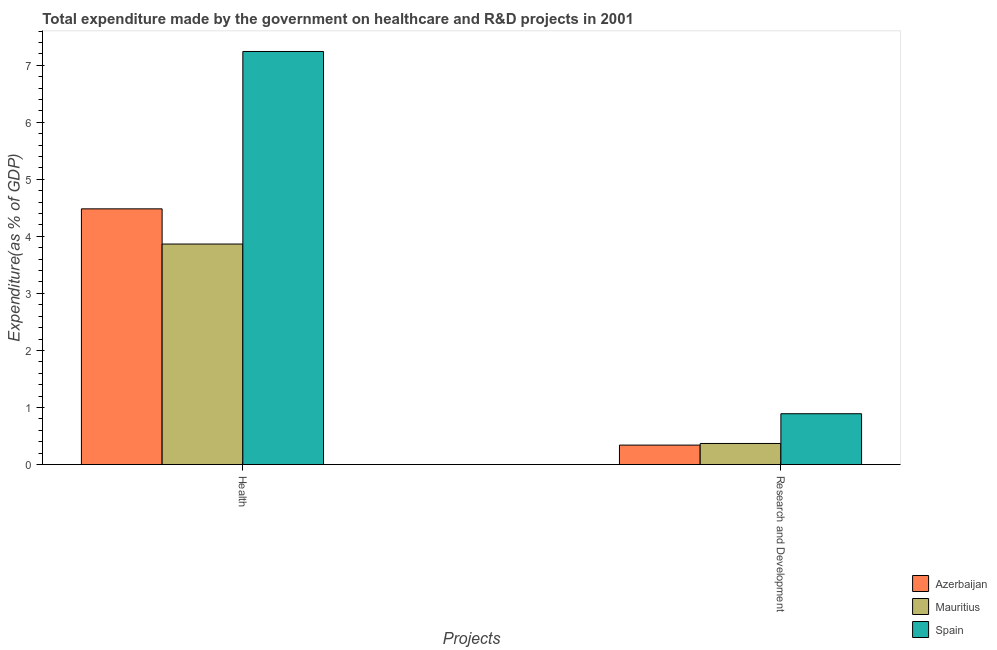Are the number of bars per tick equal to the number of legend labels?
Make the answer very short. Yes. What is the label of the 1st group of bars from the left?
Give a very brief answer. Health. What is the expenditure in r&d in Mauritius?
Your answer should be very brief. 0.37. Across all countries, what is the maximum expenditure in r&d?
Keep it short and to the point. 0.89. Across all countries, what is the minimum expenditure in healthcare?
Make the answer very short. 3.87. In which country was the expenditure in r&d maximum?
Make the answer very short. Spain. In which country was the expenditure in healthcare minimum?
Your answer should be compact. Mauritius. What is the total expenditure in r&d in the graph?
Keep it short and to the point. 1.6. What is the difference between the expenditure in healthcare in Spain and that in Mauritius?
Your answer should be compact. 3.38. What is the difference between the expenditure in r&d in Mauritius and the expenditure in healthcare in Spain?
Give a very brief answer. -6.87. What is the average expenditure in healthcare per country?
Make the answer very short. 5.2. What is the difference between the expenditure in healthcare and expenditure in r&d in Azerbaijan?
Ensure brevity in your answer.  4.14. In how many countries, is the expenditure in healthcare greater than 2.4 %?
Offer a terse response. 3. What is the ratio of the expenditure in healthcare in Spain to that in Azerbaijan?
Your response must be concise. 1.62. In how many countries, is the expenditure in r&d greater than the average expenditure in r&d taken over all countries?
Your response must be concise. 1. What does the 2nd bar from the right in Health represents?
Your answer should be compact. Mauritius. How many bars are there?
Make the answer very short. 6. How are the legend labels stacked?
Give a very brief answer. Vertical. What is the title of the graph?
Your answer should be very brief. Total expenditure made by the government on healthcare and R&D projects in 2001. Does "New Caledonia" appear as one of the legend labels in the graph?
Your response must be concise. No. What is the label or title of the X-axis?
Offer a terse response. Projects. What is the label or title of the Y-axis?
Your answer should be very brief. Expenditure(as % of GDP). What is the Expenditure(as % of GDP) of Azerbaijan in Health?
Provide a succinct answer. 4.48. What is the Expenditure(as % of GDP) in Mauritius in Health?
Your response must be concise. 3.87. What is the Expenditure(as % of GDP) in Spain in Health?
Provide a succinct answer. 7.24. What is the Expenditure(as % of GDP) in Azerbaijan in Research and Development?
Your answer should be very brief. 0.34. What is the Expenditure(as % of GDP) in Mauritius in Research and Development?
Give a very brief answer. 0.37. What is the Expenditure(as % of GDP) of Spain in Research and Development?
Ensure brevity in your answer.  0.89. Across all Projects, what is the maximum Expenditure(as % of GDP) of Azerbaijan?
Offer a terse response. 4.48. Across all Projects, what is the maximum Expenditure(as % of GDP) in Mauritius?
Give a very brief answer. 3.87. Across all Projects, what is the maximum Expenditure(as % of GDP) of Spain?
Offer a terse response. 7.24. Across all Projects, what is the minimum Expenditure(as % of GDP) in Azerbaijan?
Offer a very short reply. 0.34. Across all Projects, what is the minimum Expenditure(as % of GDP) in Mauritius?
Offer a very short reply. 0.37. Across all Projects, what is the minimum Expenditure(as % of GDP) in Spain?
Make the answer very short. 0.89. What is the total Expenditure(as % of GDP) of Azerbaijan in the graph?
Ensure brevity in your answer.  4.82. What is the total Expenditure(as % of GDP) in Mauritius in the graph?
Offer a terse response. 4.23. What is the total Expenditure(as % of GDP) of Spain in the graph?
Make the answer very short. 8.13. What is the difference between the Expenditure(as % of GDP) of Azerbaijan in Health and that in Research and Development?
Keep it short and to the point. 4.14. What is the difference between the Expenditure(as % of GDP) in Mauritius in Health and that in Research and Development?
Provide a short and direct response. 3.5. What is the difference between the Expenditure(as % of GDP) of Spain in Health and that in Research and Development?
Offer a very short reply. 6.35. What is the difference between the Expenditure(as % of GDP) in Azerbaijan in Health and the Expenditure(as % of GDP) in Mauritius in Research and Development?
Your response must be concise. 4.11. What is the difference between the Expenditure(as % of GDP) in Azerbaijan in Health and the Expenditure(as % of GDP) in Spain in Research and Development?
Ensure brevity in your answer.  3.59. What is the difference between the Expenditure(as % of GDP) of Mauritius in Health and the Expenditure(as % of GDP) of Spain in Research and Development?
Your answer should be compact. 2.98. What is the average Expenditure(as % of GDP) in Azerbaijan per Projects?
Your answer should be very brief. 2.41. What is the average Expenditure(as % of GDP) in Mauritius per Projects?
Your response must be concise. 2.12. What is the average Expenditure(as % of GDP) of Spain per Projects?
Offer a terse response. 4.07. What is the difference between the Expenditure(as % of GDP) in Azerbaijan and Expenditure(as % of GDP) in Mauritius in Health?
Offer a terse response. 0.62. What is the difference between the Expenditure(as % of GDP) of Azerbaijan and Expenditure(as % of GDP) of Spain in Health?
Keep it short and to the point. -2.76. What is the difference between the Expenditure(as % of GDP) of Mauritius and Expenditure(as % of GDP) of Spain in Health?
Provide a short and direct response. -3.38. What is the difference between the Expenditure(as % of GDP) in Azerbaijan and Expenditure(as % of GDP) in Mauritius in Research and Development?
Your answer should be compact. -0.03. What is the difference between the Expenditure(as % of GDP) in Azerbaijan and Expenditure(as % of GDP) in Spain in Research and Development?
Provide a succinct answer. -0.55. What is the difference between the Expenditure(as % of GDP) of Mauritius and Expenditure(as % of GDP) of Spain in Research and Development?
Your response must be concise. -0.52. What is the ratio of the Expenditure(as % of GDP) of Azerbaijan in Health to that in Research and Development?
Provide a succinct answer. 13.18. What is the ratio of the Expenditure(as % of GDP) in Mauritius in Health to that in Research and Development?
Give a very brief answer. 10.48. What is the ratio of the Expenditure(as % of GDP) in Spain in Health to that in Research and Development?
Keep it short and to the point. 8.13. What is the difference between the highest and the second highest Expenditure(as % of GDP) in Azerbaijan?
Give a very brief answer. 4.14. What is the difference between the highest and the second highest Expenditure(as % of GDP) in Mauritius?
Ensure brevity in your answer.  3.5. What is the difference between the highest and the second highest Expenditure(as % of GDP) of Spain?
Your answer should be very brief. 6.35. What is the difference between the highest and the lowest Expenditure(as % of GDP) in Azerbaijan?
Provide a short and direct response. 4.14. What is the difference between the highest and the lowest Expenditure(as % of GDP) of Mauritius?
Offer a very short reply. 3.5. What is the difference between the highest and the lowest Expenditure(as % of GDP) in Spain?
Offer a terse response. 6.35. 